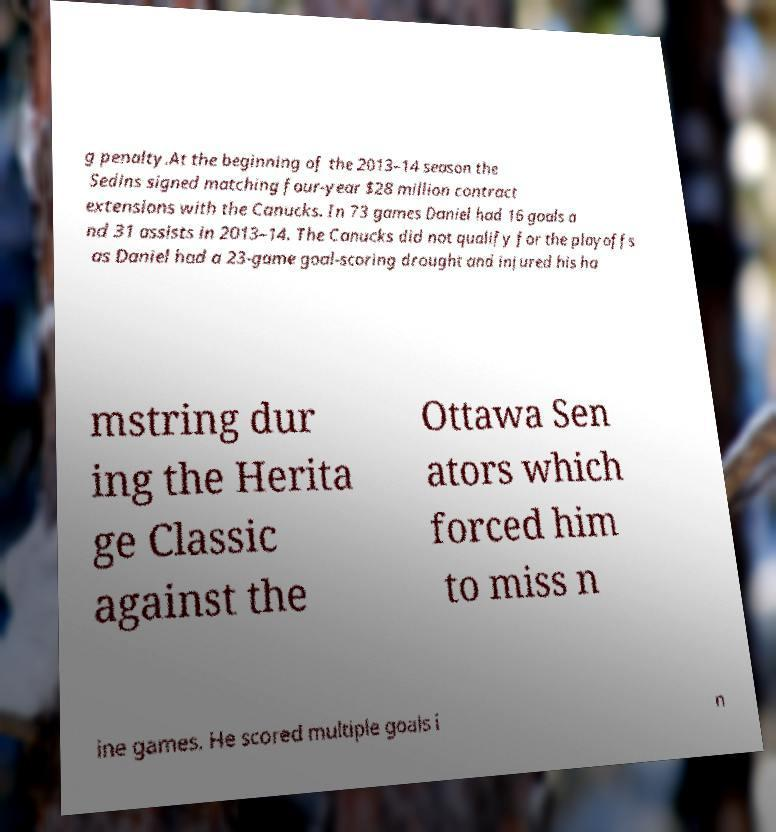Can you read and provide the text displayed in the image?This photo seems to have some interesting text. Can you extract and type it out for me? g penalty.At the beginning of the 2013–14 season the Sedins signed matching four-year $28 million contract extensions with the Canucks. In 73 games Daniel had 16 goals a nd 31 assists in 2013–14. The Canucks did not qualify for the playoffs as Daniel had a 23-game goal-scoring drought and injured his ha mstring dur ing the Herita ge Classic against the Ottawa Sen ators which forced him to miss n ine games. He scored multiple goals i n 